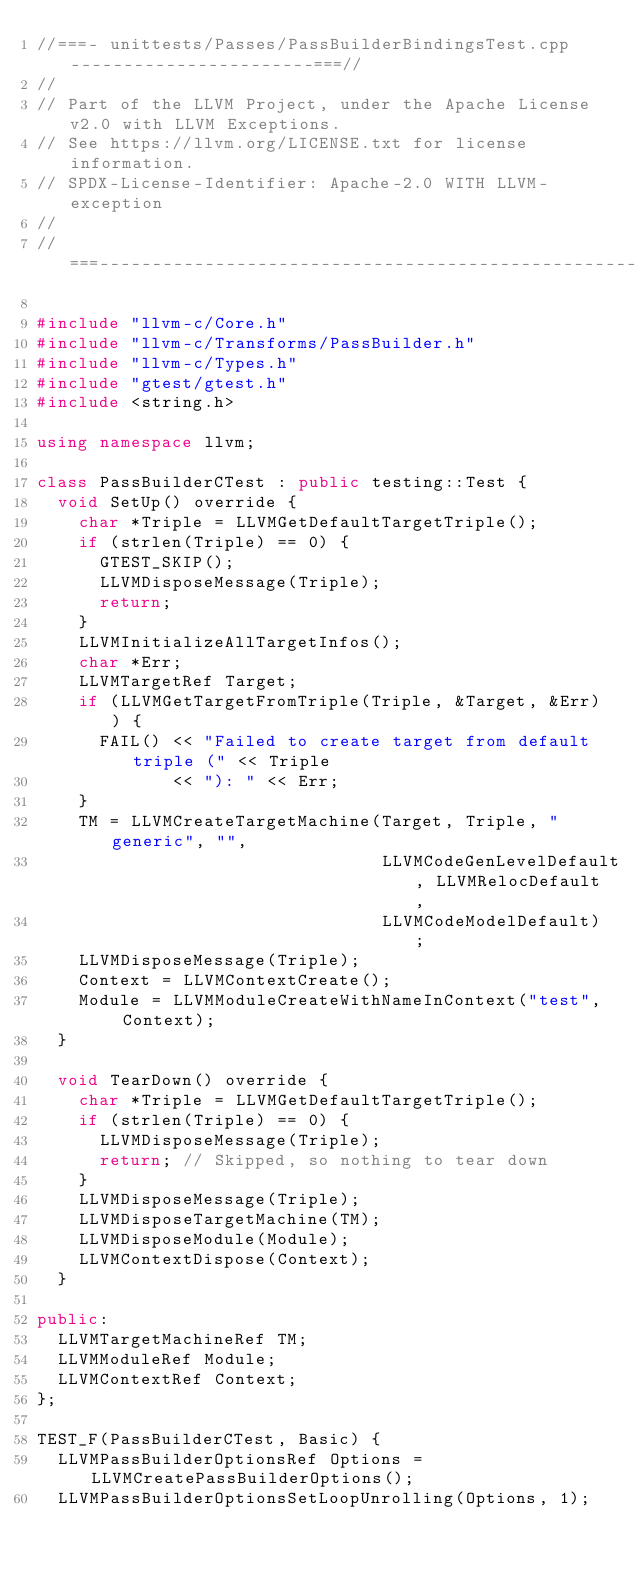<code> <loc_0><loc_0><loc_500><loc_500><_C++_>//===- unittests/Passes/PassBuilderBindingsTest.cpp -----------------------===//
//
// Part of the LLVM Project, under the Apache License v2.0 with LLVM Exceptions.
// See https://llvm.org/LICENSE.txt for license information.
// SPDX-License-Identifier: Apache-2.0 WITH LLVM-exception
//
//===----------------------------------------------------------------------===//

#include "llvm-c/Core.h"
#include "llvm-c/Transforms/PassBuilder.h"
#include "llvm-c/Types.h"
#include "gtest/gtest.h"
#include <string.h>

using namespace llvm;

class PassBuilderCTest : public testing::Test {
  void SetUp() override {
    char *Triple = LLVMGetDefaultTargetTriple();
    if (strlen(Triple) == 0) {
      GTEST_SKIP();
      LLVMDisposeMessage(Triple);
      return;
    }
    LLVMInitializeAllTargetInfos();
    char *Err;
    LLVMTargetRef Target;
    if (LLVMGetTargetFromTriple(Triple, &Target, &Err)) {
      FAIL() << "Failed to create target from default triple (" << Triple
             << "): " << Err;
    }
    TM = LLVMCreateTargetMachine(Target, Triple, "generic", "",
                                 LLVMCodeGenLevelDefault, LLVMRelocDefault,
                                 LLVMCodeModelDefault);
    LLVMDisposeMessage(Triple);
    Context = LLVMContextCreate();
    Module = LLVMModuleCreateWithNameInContext("test", Context);
  }

  void TearDown() override {
    char *Triple = LLVMGetDefaultTargetTriple();
    if (strlen(Triple) == 0) {
      LLVMDisposeMessage(Triple);
      return; // Skipped, so nothing to tear down
    }
    LLVMDisposeMessage(Triple);
    LLVMDisposeTargetMachine(TM);
    LLVMDisposeModule(Module);
    LLVMContextDispose(Context);
  }

public:
  LLVMTargetMachineRef TM;
  LLVMModuleRef Module;
  LLVMContextRef Context;
};

TEST_F(PassBuilderCTest, Basic) {
  LLVMPassBuilderOptionsRef Options = LLVMCreatePassBuilderOptions();
  LLVMPassBuilderOptionsSetLoopUnrolling(Options, 1);</code> 